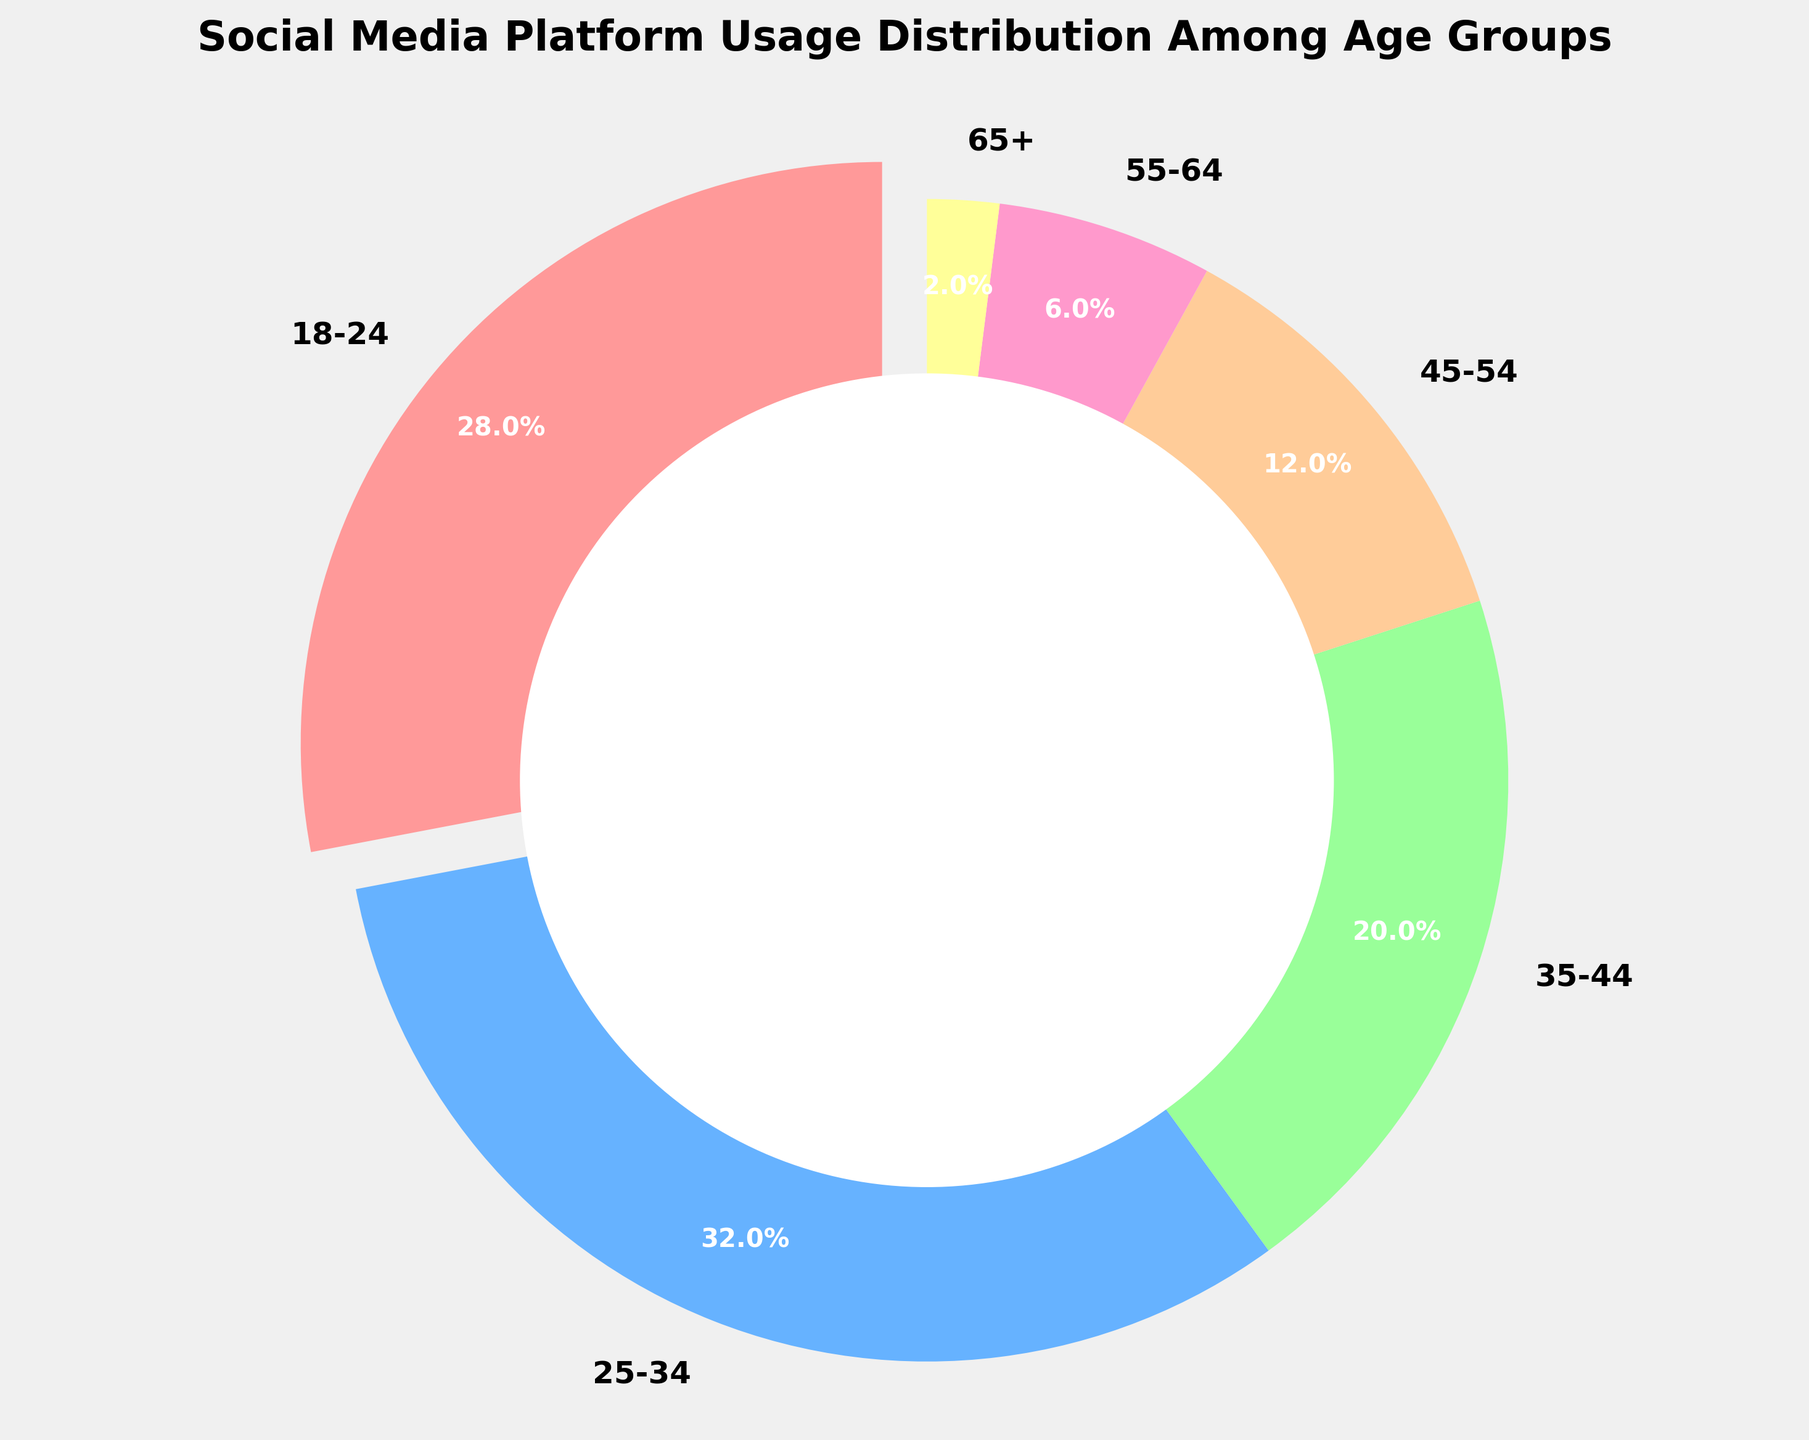What is the largest age group that uses social media platforms according to the pie chart? Identify the slice with the largest percentage. The largest slice corresponds to the 25-34 age group with 32%.
Answer: 25-34 Which age group has the smallest percentage of social media platform usage? Look for the smallest slice in the pie chart, which corresponds to the 65+ age group with 2%.
Answer: 65+ How much more is the social media usage among the 25-34 age group compared to the 55-64 age group? Subtract the percentage of the 55-64 age group from the 25-34 age group: 32% - 6% = 26%.
Answer: 26% What is the total percentage of social media users ages 35 and above? Sum the percentages of the age groups 35-44, 45-54, 55-64, and 65+: 20% + 12% + 6% + 2% = 40%.
Answer: 40% Which age groups have more than 20% of social media usage? Identify slices with percentages greater than 20%: the 18-24 age group (28%) and the 25-34 age group (32%).
Answer: 18-24, 25-34 By how much does the percentage of social media usage of the 18-24 age group differ from that of the 35-44 age group? Subtract the percentage of the 35-44 age group from the 18-24 age group: 28% - 20% = 8%.
Answer: 8% What is the combined usage percentage of the 45-54 and 55-64 age groups? Add up the percentages of the 45-54 and 55-64 age groups: 12% + 6% = 18%.
Answer: 18% Considering the visual attributes, which color represents the 18-24 age group in the pie chart? Identify the color of the slice corresponding to the 18-24 age group, which is red based on the given colors array.
Answer: red If you combine the 18-24 and 25-34 age groups, what fraction of the pie chart do they represent? Sum the percentages of the 18-24 and 25-34 age groups: 28% + 32% = 60%, which is equivalent to 3/5 of the pie.
Answer: 3/5 What percentage of the pie chart is represented by age groups 55-64 and 65+? Add the percentages of the 55-64 and 65+ age groups: 6% + 2% = 8%.
Answer: 8% 